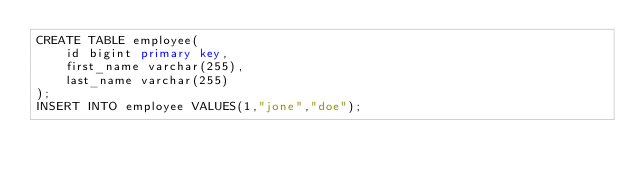Convert code to text. <code><loc_0><loc_0><loc_500><loc_500><_SQL_>CREATE TABLE employee(
    id bigint primary key,
    first_name varchar(255),
    last_name varchar(255)
);
INSERT INTO employee VALUES(1,"jone","doe");</code> 